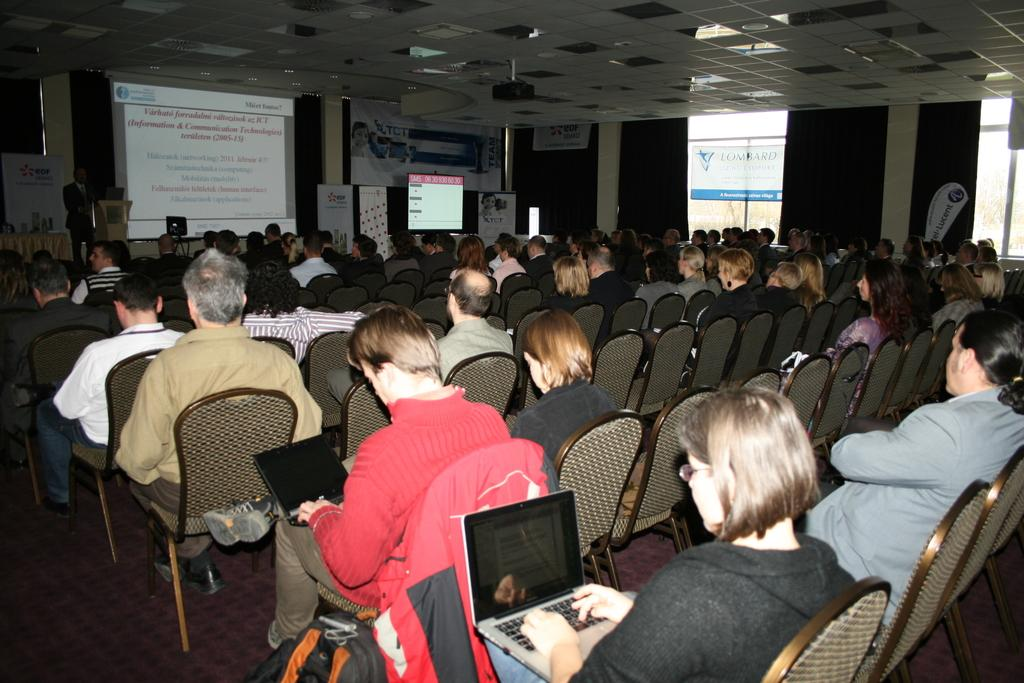What are the people in the image doing? The people are sitting on chairs and looking at a screen. What might be projecting the image on the screen? There is a projector in the image, which could be projecting the image on the screen. What device might be connected to the projector? There is a laptop in the image, which could be connected to the projector. Is there any personal belonging visible in the image? Yes, there is a bag in the image. What type of crime is being committed in the image? There is no indication of any crime being committed in the image. Can you tell me how many drums are visible in the image? There are no drums present in the image. 